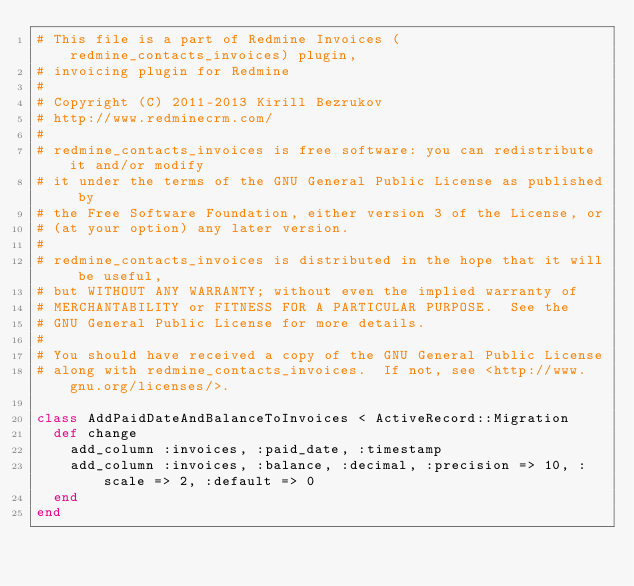<code> <loc_0><loc_0><loc_500><loc_500><_Ruby_># This file is a part of Redmine Invoices (redmine_contacts_invoices) plugin,
# invoicing plugin for Redmine
#
# Copyright (C) 2011-2013 Kirill Bezrukov
# http://www.redminecrm.com/
#
# redmine_contacts_invoices is free software: you can redistribute it and/or modify
# it under the terms of the GNU General Public License as published by
# the Free Software Foundation, either version 3 of the License, or
# (at your option) any later version.
#
# redmine_contacts_invoices is distributed in the hope that it will be useful,
# but WITHOUT ANY WARRANTY; without even the implied warranty of
# MERCHANTABILITY or FITNESS FOR A PARTICULAR PURPOSE.  See the
# GNU General Public License for more details.
#
# You should have received a copy of the GNU General Public License
# along with redmine_contacts_invoices.  If not, see <http://www.gnu.org/licenses/>.

class AddPaidDateAndBalanceToInvoices < ActiveRecord::Migration
  def change
    add_column :invoices, :paid_date, :timestamp 
    add_column :invoices, :balance, :decimal, :precision => 10, :scale => 2, :default => 0 
  end
end
</code> 